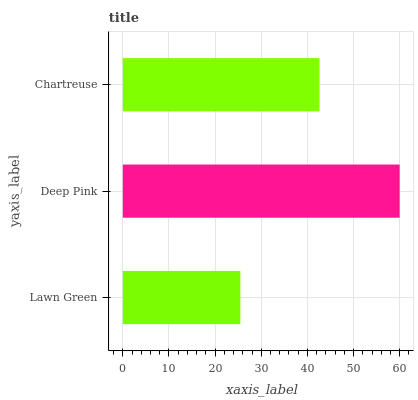Is Lawn Green the minimum?
Answer yes or no. Yes. Is Deep Pink the maximum?
Answer yes or no. Yes. Is Chartreuse the minimum?
Answer yes or no. No. Is Chartreuse the maximum?
Answer yes or no. No. Is Deep Pink greater than Chartreuse?
Answer yes or no. Yes. Is Chartreuse less than Deep Pink?
Answer yes or no. Yes. Is Chartreuse greater than Deep Pink?
Answer yes or no. No. Is Deep Pink less than Chartreuse?
Answer yes or no. No. Is Chartreuse the high median?
Answer yes or no. Yes. Is Chartreuse the low median?
Answer yes or no. Yes. Is Lawn Green the high median?
Answer yes or no. No. Is Deep Pink the low median?
Answer yes or no. No. 